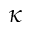Convert formula to latex. <formula><loc_0><loc_0><loc_500><loc_500>\kappa</formula> 